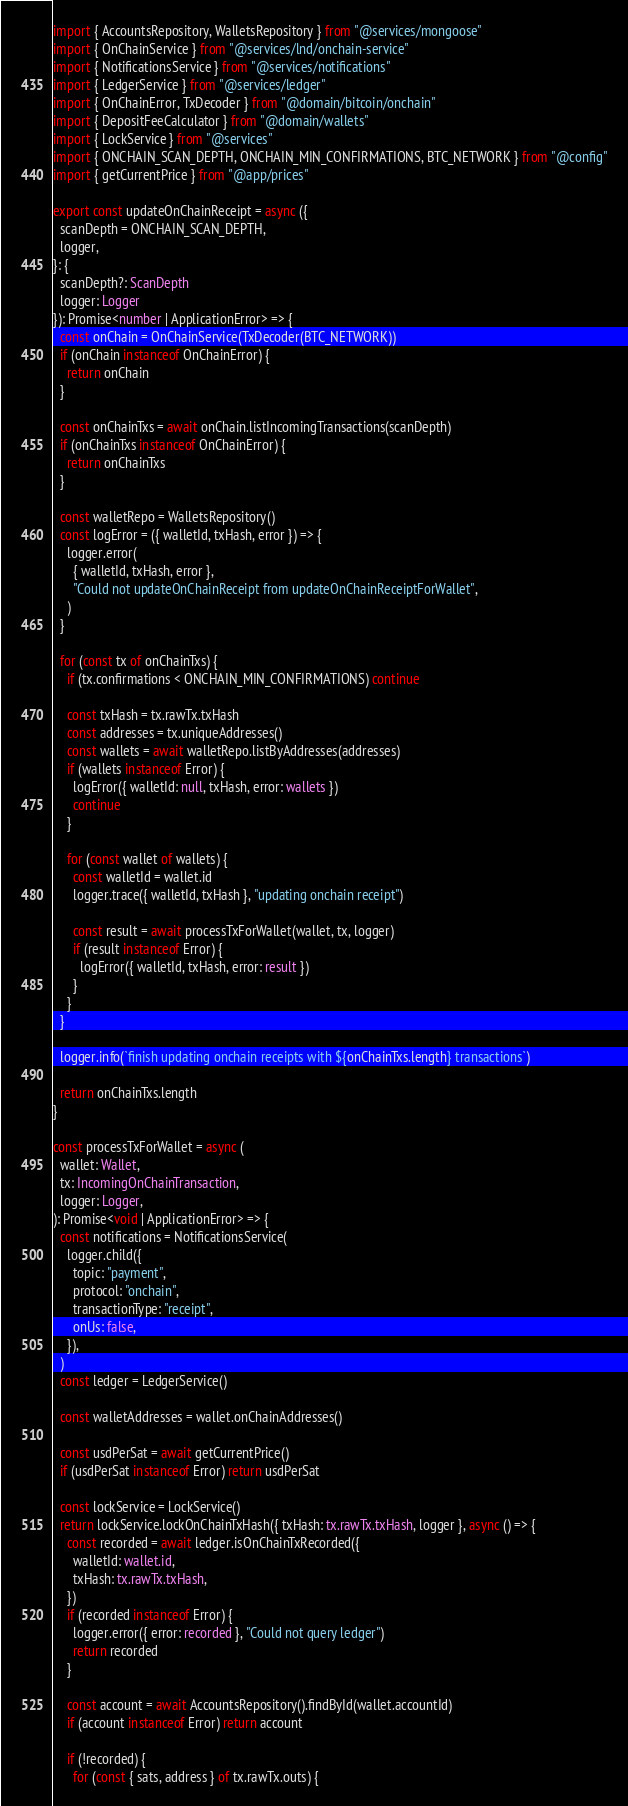Convert code to text. <code><loc_0><loc_0><loc_500><loc_500><_TypeScript_>import { AccountsRepository, WalletsRepository } from "@services/mongoose"
import { OnChainService } from "@services/lnd/onchain-service"
import { NotificationsService } from "@services/notifications"
import { LedgerService } from "@services/ledger"
import { OnChainError, TxDecoder } from "@domain/bitcoin/onchain"
import { DepositFeeCalculator } from "@domain/wallets"
import { LockService } from "@services"
import { ONCHAIN_SCAN_DEPTH, ONCHAIN_MIN_CONFIRMATIONS, BTC_NETWORK } from "@config"
import { getCurrentPrice } from "@app/prices"

export const updateOnChainReceipt = async ({
  scanDepth = ONCHAIN_SCAN_DEPTH,
  logger,
}: {
  scanDepth?: ScanDepth
  logger: Logger
}): Promise<number | ApplicationError> => {
  const onChain = OnChainService(TxDecoder(BTC_NETWORK))
  if (onChain instanceof OnChainError) {
    return onChain
  }

  const onChainTxs = await onChain.listIncomingTransactions(scanDepth)
  if (onChainTxs instanceof OnChainError) {
    return onChainTxs
  }

  const walletRepo = WalletsRepository()
  const logError = ({ walletId, txHash, error }) => {
    logger.error(
      { walletId, txHash, error },
      "Could not updateOnChainReceipt from updateOnChainReceiptForWallet",
    )
  }

  for (const tx of onChainTxs) {
    if (tx.confirmations < ONCHAIN_MIN_CONFIRMATIONS) continue

    const txHash = tx.rawTx.txHash
    const addresses = tx.uniqueAddresses()
    const wallets = await walletRepo.listByAddresses(addresses)
    if (wallets instanceof Error) {
      logError({ walletId: null, txHash, error: wallets })
      continue
    }

    for (const wallet of wallets) {
      const walletId = wallet.id
      logger.trace({ walletId, txHash }, "updating onchain receipt")

      const result = await processTxForWallet(wallet, tx, logger)
      if (result instanceof Error) {
        logError({ walletId, txHash, error: result })
      }
    }
  }

  logger.info(`finish updating onchain receipts with ${onChainTxs.length} transactions`)

  return onChainTxs.length
}

const processTxForWallet = async (
  wallet: Wallet,
  tx: IncomingOnChainTransaction,
  logger: Logger,
): Promise<void | ApplicationError> => {
  const notifications = NotificationsService(
    logger.child({
      topic: "payment",
      protocol: "onchain",
      transactionType: "receipt",
      onUs: false,
    }),
  )
  const ledger = LedgerService()

  const walletAddresses = wallet.onChainAddresses()

  const usdPerSat = await getCurrentPrice()
  if (usdPerSat instanceof Error) return usdPerSat

  const lockService = LockService()
  return lockService.lockOnChainTxHash({ txHash: tx.rawTx.txHash, logger }, async () => {
    const recorded = await ledger.isOnChainTxRecorded({
      walletId: wallet.id,
      txHash: tx.rawTx.txHash,
    })
    if (recorded instanceof Error) {
      logger.error({ error: recorded }, "Could not query ledger")
      return recorded
    }

    const account = await AccountsRepository().findById(wallet.accountId)
    if (account instanceof Error) return account

    if (!recorded) {
      for (const { sats, address } of tx.rawTx.outs) {</code> 